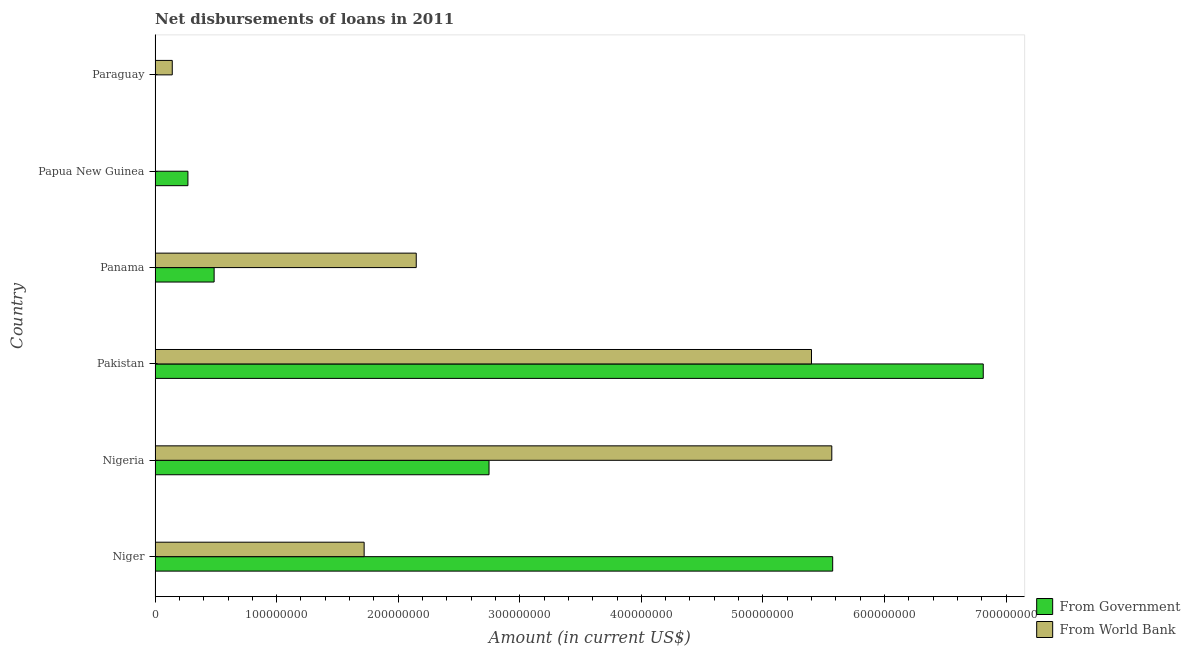Are the number of bars per tick equal to the number of legend labels?
Provide a short and direct response. No. In how many cases, is the number of bars for a given country not equal to the number of legend labels?
Your answer should be very brief. 2. What is the net disbursements of loan from world bank in Pakistan?
Make the answer very short. 5.40e+08. Across all countries, what is the maximum net disbursements of loan from government?
Your answer should be compact. 6.81e+08. In which country was the net disbursements of loan from world bank maximum?
Offer a terse response. Nigeria. What is the total net disbursements of loan from world bank in the graph?
Your answer should be compact. 1.50e+09. What is the difference between the net disbursements of loan from world bank in Nigeria and that in Panama?
Provide a short and direct response. 3.42e+08. What is the difference between the net disbursements of loan from government in Pakistan and the net disbursements of loan from world bank in Papua New Guinea?
Your answer should be compact. 6.81e+08. What is the average net disbursements of loan from government per country?
Your answer should be compact. 2.65e+08. What is the difference between the net disbursements of loan from government and net disbursements of loan from world bank in Pakistan?
Give a very brief answer. 1.41e+08. What is the ratio of the net disbursements of loan from government in Nigeria to that in Panama?
Your answer should be compact. 5.65. Is the difference between the net disbursements of loan from government in Nigeria and Panama greater than the difference between the net disbursements of loan from world bank in Nigeria and Panama?
Offer a very short reply. No. What is the difference between the highest and the second highest net disbursements of loan from government?
Give a very brief answer. 1.24e+08. What is the difference between the highest and the lowest net disbursements of loan from government?
Your response must be concise. 6.81e+08. Are all the bars in the graph horizontal?
Your response must be concise. Yes. How many countries are there in the graph?
Provide a succinct answer. 6. Does the graph contain any zero values?
Ensure brevity in your answer.  Yes. Does the graph contain grids?
Ensure brevity in your answer.  No. How are the legend labels stacked?
Provide a short and direct response. Vertical. What is the title of the graph?
Ensure brevity in your answer.  Net disbursements of loans in 2011. What is the Amount (in current US$) in From Government in Niger?
Ensure brevity in your answer.  5.57e+08. What is the Amount (in current US$) in From World Bank in Niger?
Provide a short and direct response. 1.72e+08. What is the Amount (in current US$) of From Government in Nigeria?
Give a very brief answer. 2.75e+08. What is the Amount (in current US$) in From World Bank in Nigeria?
Make the answer very short. 5.57e+08. What is the Amount (in current US$) of From Government in Pakistan?
Keep it short and to the point. 6.81e+08. What is the Amount (in current US$) in From World Bank in Pakistan?
Keep it short and to the point. 5.40e+08. What is the Amount (in current US$) of From Government in Panama?
Offer a very short reply. 4.86e+07. What is the Amount (in current US$) of From World Bank in Panama?
Your response must be concise. 2.15e+08. What is the Amount (in current US$) in From Government in Papua New Guinea?
Provide a succinct answer. 2.70e+07. What is the Amount (in current US$) in From World Bank in Papua New Guinea?
Provide a succinct answer. 0. What is the Amount (in current US$) in From World Bank in Paraguay?
Provide a succinct answer. 1.42e+07. Across all countries, what is the maximum Amount (in current US$) of From Government?
Provide a succinct answer. 6.81e+08. Across all countries, what is the maximum Amount (in current US$) in From World Bank?
Provide a short and direct response. 5.57e+08. What is the total Amount (in current US$) in From Government in the graph?
Provide a succinct answer. 1.59e+09. What is the total Amount (in current US$) in From World Bank in the graph?
Make the answer very short. 1.50e+09. What is the difference between the Amount (in current US$) of From Government in Niger and that in Nigeria?
Make the answer very short. 2.83e+08. What is the difference between the Amount (in current US$) of From World Bank in Niger and that in Nigeria?
Provide a succinct answer. -3.85e+08. What is the difference between the Amount (in current US$) in From Government in Niger and that in Pakistan?
Provide a short and direct response. -1.24e+08. What is the difference between the Amount (in current US$) in From World Bank in Niger and that in Pakistan?
Offer a very short reply. -3.68e+08. What is the difference between the Amount (in current US$) in From Government in Niger and that in Panama?
Offer a terse response. 5.09e+08. What is the difference between the Amount (in current US$) of From World Bank in Niger and that in Panama?
Your answer should be very brief. -4.29e+07. What is the difference between the Amount (in current US$) in From Government in Niger and that in Papua New Guinea?
Ensure brevity in your answer.  5.30e+08. What is the difference between the Amount (in current US$) of From World Bank in Niger and that in Paraguay?
Ensure brevity in your answer.  1.58e+08. What is the difference between the Amount (in current US$) in From Government in Nigeria and that in Pakistan?
Offer a terse response. -4.07e+08. What is the difference between the Amount (in current US$) of From World Bank in Nigeria and that in Pakistan?
Offer a terse response. 1.67e+07. What is the difference between the Amount (in current US$) in From Government in Nigeria and that in Panama?
Offer a very short reply. 2.26e+08. What is the difference between the Amount (in current US$) of From World Bank in Nigeria and that in Panama?
Your answer should be very brief. 3.42e+08. What is the difference between the Amount (in current US$) in From Government in Nigeria and that in Papua New Guinea?
Make the answer very short. 2.48e+08. What is the difference between the Amount (in current US$) of From World Bank in Nigeria and that in Paraguay?
Offer a terse response. 5.43e+08. What is the difference between the Amount (in current US$) in From Government in Pakistan and that in Panama?
Give a very brief answer. 6.33e+08. What is the difference between the Amount (in current US$) in From World Bank in Pakistan and that in Panama?
Make the answer very short. 3.25e+08. What is the difference between the Amount (in current US$) in From Government in Pakistan and that in Papua New Guinea?
Your answer should be very brief. 6.54e+08. What is the difference between the Amount (in current US$) in From World Bank in Pakistan and that in Paraguay?
Keep it short and to the point. 5.26e+08. What is the difference between the Amount (in current US$) in From Government in Panama and that in Papua New Guinea?
Ensure brevity in your answer.  2.16e+07. What is the difference between the Amount (in current US$) of From World Bank in Panama and that in Paraguay?
Make the answer very short. 2.01e+08. What is the difference between the Amount (in current US$) of From Government in Niger and the Amount (in current US$) of From World Bank in Nigeria?
Your response must be concise. 7.30e+05. What is the difference between the Amount (in current US$) of From Government in Niger and the Amount (in current US$) of From World Bank in Pakistan?
Your response must be concise. 1.74e+07. What is the difference between the Amount (in current US$) in From Government in Niger and the Amount (in current US$) in From World Bank in Panama?
Make the answer very short. 3.43e+08. What is the difference between the Amount (in current US$) in From Government in Niger and the Amount (in current US$) in From World Bank in Paraguay?
Offer a very short reply. 5.43e+08. What is the difference between the Amount (in current US$) of From Government in Nigeria and the Amount (in current US$) of From World Bank in Pakistan?
Provide a succinct answer. -2.65e+08. What is the difference between the Amount (in current US$) of From Government in Nigeria and the Amount (in current US$) of From World Bank in Panama?
Your answer should be very brief. 5.99e+07. What is the difference between the Amount (in current US$) of From Government in Nigeria and the Amount (in current US$) of From World Bank in Paraguay?
Offer a terse response. 2.61e+08. What is the difference between the Amount (in current US$) in From Government in Pakistan and the Amount (in current US$) in From World Bank in Panama?
Your answer should be very brief. 4.66e+08. What is the difference between the Amount (in current US$) in From Government in Pakistan and the Amount (in current US$) in From World Bank in Paraguay?
Offer a very short reply. 6.67e+08. What is the difference between the Amount (in current US$) in From Government in Panama and the Amount (in current US$) in From World Bank in Paraguay?
Provide a succinct answer. 3.44e+07. What is the difference between the Amount (in current US$) in From Government in Papua New Guinea and the Amount (in current US$) in From World Bank in Paraguay?
Give a very brief answer. 1.29e+07. What is the average Amount (in current US$) in From Government per country?
Provide a succinct answer. 2.65e+08. What is the average Amount (in current US$) in From World Bank per country?
Your response must be concise. 2.50e+08. What is the difference between the Amount (in current US$) in From Government and Amount (in current US$) in From World Bank in Niger?
Give a very brief answer. 3.85e+08. What is the difference between the Amount (in current US$) in From Government and Amount (in current US$) in From World Bank in Nigeria?
Your response must be concise. -2.82e+08. What is the difference between the Amount (in current US$) in From Government and Amount (in current US$) in From World Bank in Pakistan?
Keep it short and to the point. 1.41e+08. What is the difference between the Amount (in current US$) in From Government and Amount (in current US$) in From World Bank in Panama?
Make the answer very short. -1.66e+08. What is the ratio of the Amount (in current US$) in From Government in Niger to that in Nigeria?
Offer a terse response. 2.03. What is the ratio of the Amount (in current US$) of From World Bank in Niger to that in Nigeria?
Keep it short and to the point. 0.31. What is the ratio of the Amount (in current US$) of From Government in Niger to that in Pakistan?
Your answer should be very brief. 0.82. What is the ratio of the Amount (in current US$) of From World Bank in Niger to that in Pakistan?
Ensure brevity in your answer.  0.32. What is the ratio of the Amount (in current US$) in From Government in Niger to that in Panama?
Make the answer very short. 11.47. What is the ratio of the Amount (in current US$) in From World Bank in Niger to that in Panama?
Ensure brevity in your answer.  0.8. What is the ratio of the Amount (in current US$) of From Government in Niger to that in Papua New Guinea?
Give a very brief answer. 20.62. What is the ratio of the Amount (in current US$) of From World Bank in Niger to that in Paraguay?
Your answer should be very brief. 12.15. What is the ratio of the Amount (in current US$) of From Government in Nigeria to that in Pakistan?
Give a very brief answer. 0.4. What is the ratio of the Amount (in current US$) in From World Bank in Nigeria to that in Pakistan?
Ensure brevity in your answer.  1.03. What is the ratio of the Amount (in current US$) of From Government in Nigeria to that in Panama?
Offer a terse response. 5.65. What is the ratio of the Amount (in current US$) of From World Bank in Nigeria to that in Panama?
Provide a short and direct response. 2.59. What is the ratio of the Amount (in current US$) in From Government in Nigeria to that in Papua New Guinea?
Provide a succinct answer. 10.17. What is the ratio of the Amount (in current US$) in From World Bank in Nigeria to that in Paraguay?
Ensure brevity in your answer.  39.34. What is the ratio of the Amount (in current US$) in From Government in Pakistan to that in Panama?
Keep it short and to the point. 14.02. What is the ratio of the Amount (in current US$) in From World Bank in Pakistan to that in Panama?
Provide a short and direct response. 2.51. What is the ratio of the Amount (in current US$) of From Government in Pakistan to that in Papua New Guinea?
Give a very brief answer. 25.21. What is the ratio of the Amount (in current US$) in From World Bank in Pakistan to that in Paraguay?
Your response must be concise. 38.16. What is the ratio of the Amount (in current US$) in From Government in Panama to that in Papua New Guinea?
Ensure brevity in your answer.  1.8. What is the ratio of the Amount (in current US$) in From World Bank in Panama to that in Paraguay?
Ensure brevity in your answer.  15.18. What is the difference between the highest and the second highest Amount (in current US$) in From Government?
Offer a very short reply. 1.24e+08. What is the difference between the highest and the second highest Amount (in current US$) of From World Bank?
Your answer should be very brief. 1.67e+07. What is the difference between the highest and the lowest Amount (in current US$) in From Government?
Make the answer very short. 6.81e+08. What is the difference between the highest and the lowest Amount (in current US$) in From World Bank?
Your response must be concise. 5.57e+08. 